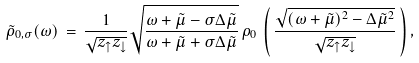<formula> <loc_0><loc_0><loc_500><loc_500>\tilde { \rho } _ { 0 , \sigma } ( \omega ) \, = \, \frac { 1 } { \sqrt { z _ { \uparrow } z _ { \downarrow } } } \sqrt { \frac { \omega + \tilde { \mu } - \sigma \Delta \tilde { \mu } } { \omega + \tilde { \mu } + \sigma \Delta \tilde { \mu } } } \, \rho _ { 0 } \, \left ( \, \frac { \sqrt { ( \omega + \tilde { \mu } ) ^ { 2 } - \Delta \tilde { \mu } ^ { 2 } } } { \sqrt { z _ { \uparrow } z _ { \downarrow } } } \, \right ) ,</formula> 